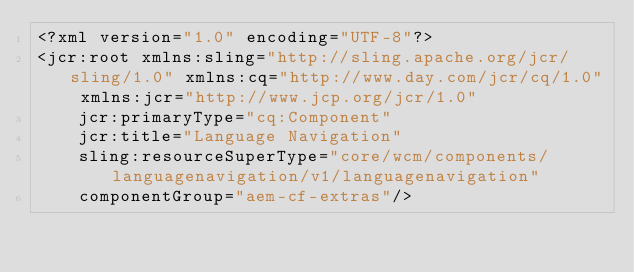Convert code to text. <code><loc_0><loc_0><loc_500><loc_500><_XML_><?xml version="1.0" encoding="UTF-8"?>
<jcr:root xmlns:sling="http://sling.apache.org/jcr/sling/1.0" xmlns:cq="http://www.day.com/jcr/cq/1.0" xmlns:jcr="http://www.jcp.org/jcr/1.0"
    jcr:primaryType="cq:Component"
    jcr:title="Language Navigation"
    sling:resourceSuperType="core/wcm/components/languagenavigation/v1/languagenavigation"
    componentGroup="aem-cf-extras"/>
</code> 